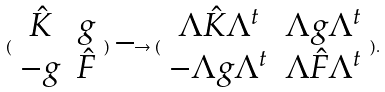<formula> <loc_0><loc_0><loc_500><loc_500>( \begin{array} { c c } \hat { K } & g \\ - g & \hat { F } \end{array} ) \longrightarrow ( \begin{array} { c c } \Lambda \hat { K } \Lambda ^ { t } & \Lambda g \Lambda ^ { t } \\ - \Lambda g \Lambda ^ { t } & \Lambda \hat { F } \Lambda ^ { t } \end{array} ) .</formula> 